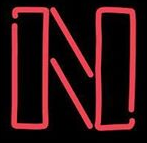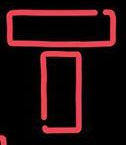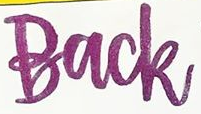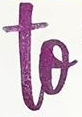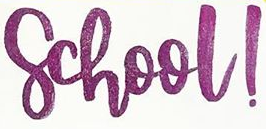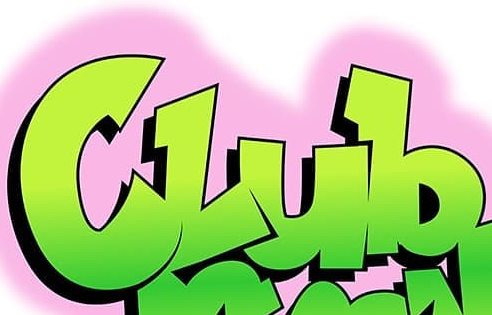Read the text content from these images in order, separated by a semicolon. N; T; Back; to; school!; Club 